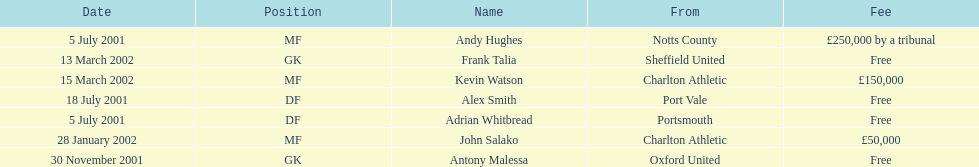Whos name is listed last on the chart? Kevin Watson. 